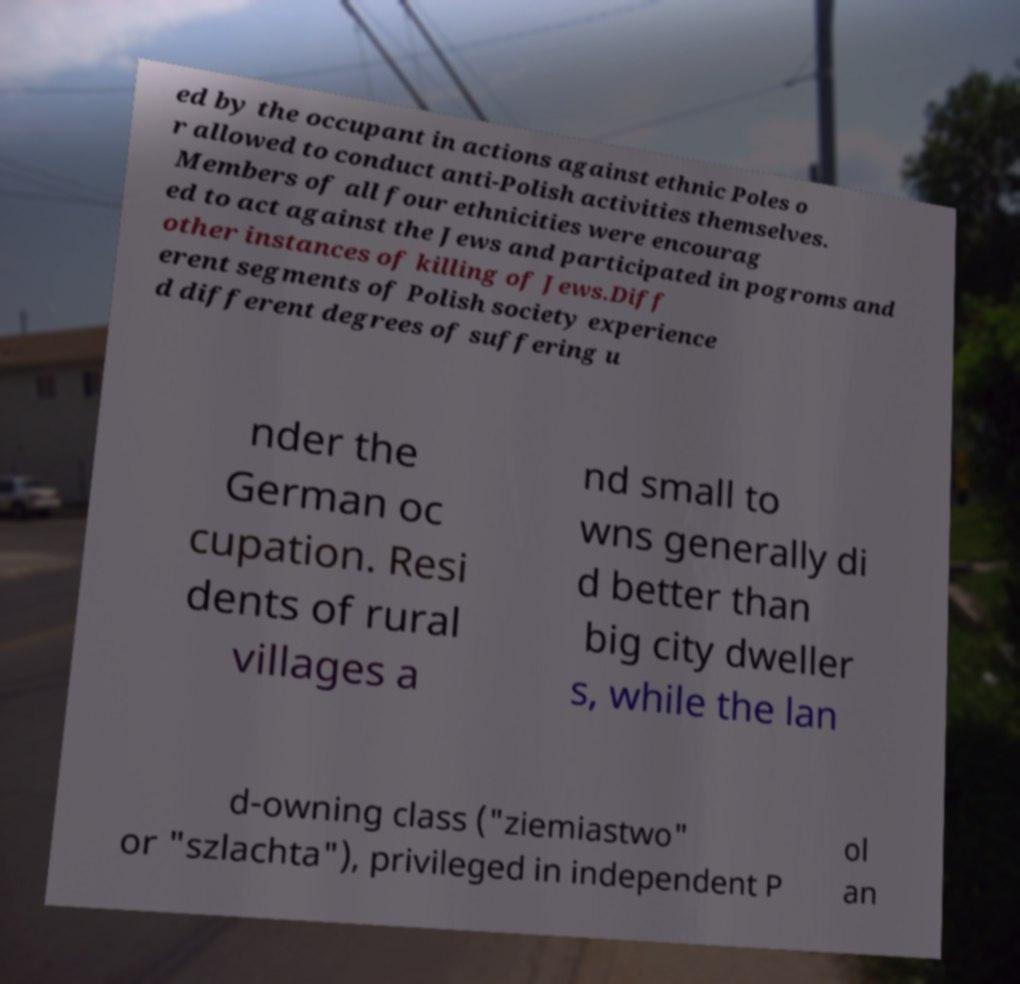Please read and relay the text visible in this image. What does it say? ed by the occupant in actions against ethnic Poles o r allowed to conduct anti-Polish activities themselves. Members of all four ethnicities were encourag ed to act against the Jews and participated in pogroms and other instances of killing of Jews.Diff erent segments of Polish society experience d different degrees of suffering u nder the German oc cupation. Resi dents of rural villages a nd small to wns generally di d better than big city dweller s, while the lan d-owning class ("ziemiastwo" or "szlachta"), privileged in independent P ol an 